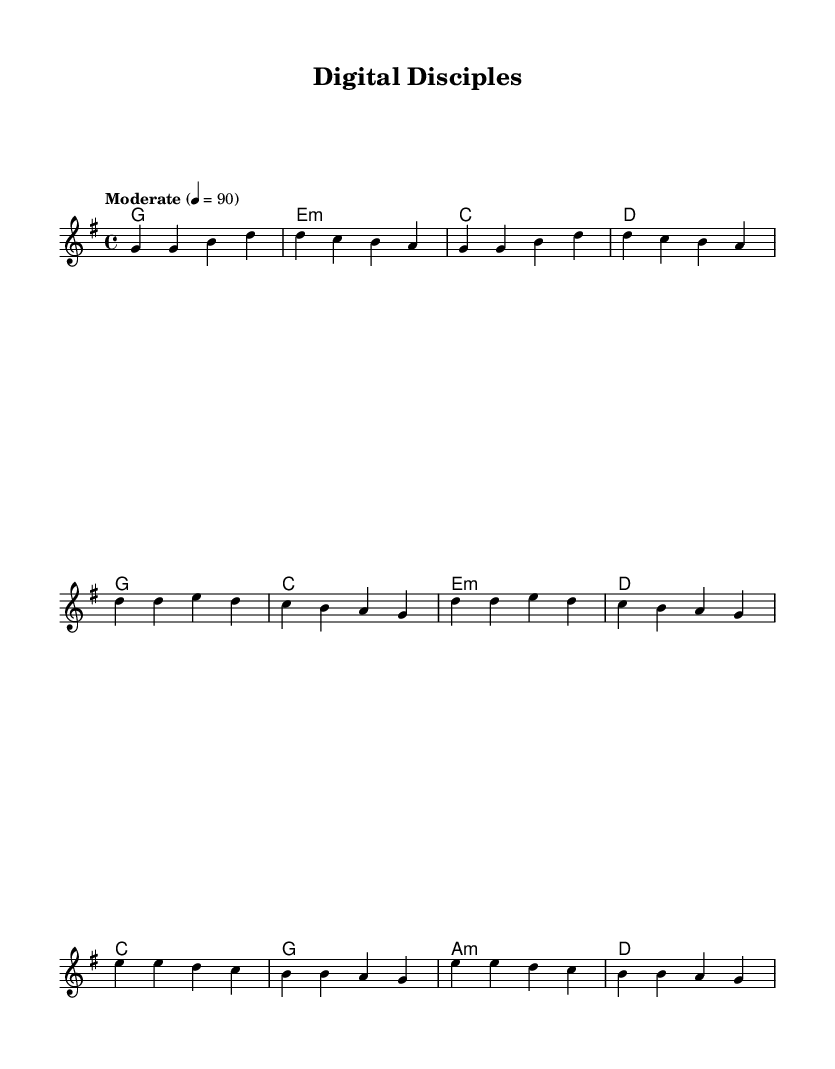What is the key signature of this music? The key signature is G major, which has one sharp (F#). This can be identified at the beginning of the sheet music.
Answer: G major What is the time signature of the piece? The time signature displayed at the start of the music is 4/4, which indicates that there are four beats per measure and the quarter note gets one beat.
Answer: 4/4 What is the tempo marking for the piece? The tempo marking in the sheet music states "Moderate" at a quarter note equals 90 beats per minute. This indicates the speed of the music.
Answer: Moderate, 90 How many measures are there in the verse section? By counting the measures in the melody within the verse portion, there are four distinct measures noted.
Answer: Four What is the primary theme of the lyrics? The lyrics express a theme of using technology responsibly while following God's guidance, emphasizing faith in the digital age.
Answer: Digital Discipleship Which chord is used in the chorus? The first chord in the chorus is D major, which can be identified in the harmonies section that corresponds with this part of the lyrics.
Answer: D major In what section do the words 'Lord, guide our hands and hearts' appear? These words appear in the bridge section of the lyrics, which follows the chorus and serves as a reflective message for guidance.
Answer: Bridge 